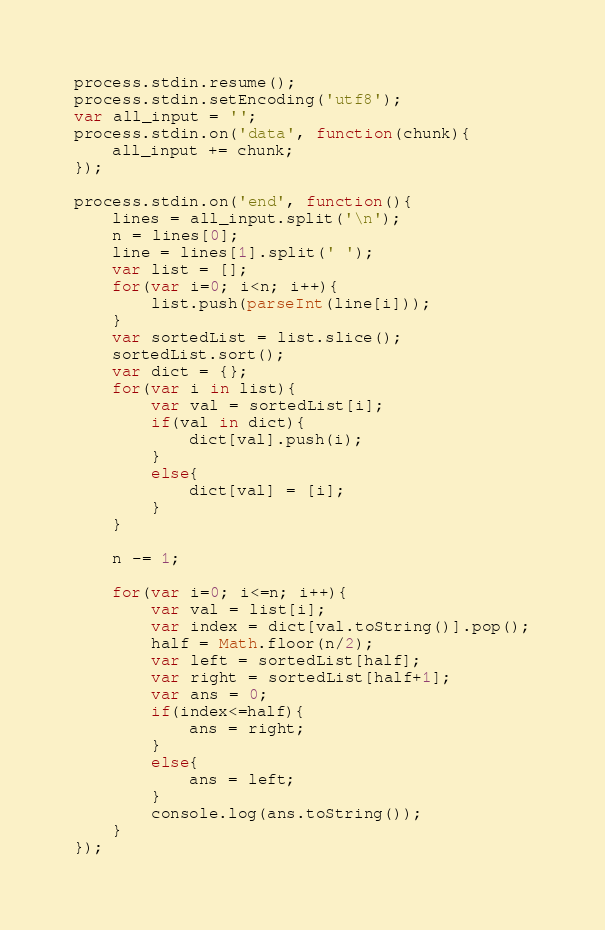<code> <loc_0><loc_0><loc_500><loc_500><_JavaScript_>process.stdin.resume();
process.stdin.setEncoding('utf8');
var all_input = '';
process.stdin.on('data', function(chunk){
    all_input += chunk;
});

process.stdin.on('end', function(){
    lines = all_input.split('\n');
    n = lines[0];
    line = lines[1].split(' ');
    var list = [];
    for(var i=0; i<n; i++){
        list.push(parseInt(line[i]));
    }
    var sortedList = list.slice();
    sortedList.sort();
    var dict = {};
    for(var i in list){
        var val = sortedList[i];
        if(val in dict){
            dict[val].push(i);
        }
        else{
            dict[val] = [i];
        }
    }
    
    n -= 1;
    
    for(var i=0; i<=n; i++){
        var val = list[i];
        var index = dict[val.toString()].pop();
        half = Math.floor(n/2);
        var left = sortedList[half];
        var right = sortedList[half+1];
        var ans = 0;
        if(index<=half){
            ans = right;
        }
        else{
            ans = left;
        }
        console.log(ans.toString());
    }
});</code> 